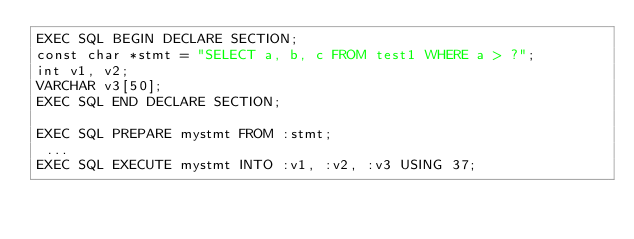Convert code to text. <code><loc_0><loc_0><loc_500><loc_500><_SQL_>EXEC SQL BEGIN DECLARE SECTION;
const char *stmt = "SELECT a, b, c FROM test1 WHERE a > ?";
int v1, v2;
VARCHAR v3[50];
EXEC SQL END DECLARE SECTION;

EXEC SQL PREPARE mystmt FROM :stmt;
 ...
EXEC SQL EXECUTE mystmt INTO :v1, :v2, :v3 USING 37;
</code> 